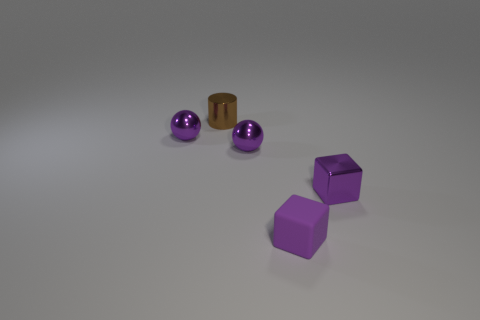Are there more purple spheres right of the small brown shiny cylinder than blue rubber things?
Your answer should be very brief. Yes. How many objects are purple balls that are left of the tiny brown cylinder or purple metal things that are to the left of the cylinder?
Make the answer very short. 1. What is the color of the tiny shiny thing that is the same shape as the small purple rubber thing?
Keep it short and to the point. Purple. What number of other tiny metal cylinders have the same color as the tiny cylinder?
Provide a succinct answer. 0. Does the tiny metallic cube have the same color as the small matte cube?
Your response must be concise. Yes. What number of things are either purple objects on the right side of the matte cube or tiny brown shiny things?
Your response must be concise. 2. What is the color of the tiny block that is right of the small thing that is in front of the metal thing that is on the right side of the small purple rubber thing?
Provide a succinct answer. Purple. The small block that is made of the same material as the tiny cylinder is what color?
Your answer should be very brief. Purple. What number of tiny objects are the same material as the tiny cylinder?
Provide a short and direct response. 3. There is a cube that is on the left side of the metal cube; is its size the same as the cylinder?
Keep it short and to the point. Yes. 